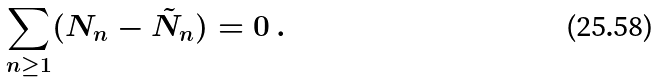<formula> <loc_0><loc_0><loc_500><loc_500>\sum _ { n \geq 1 } ( N _ { n } - \tilde { N } _ { n } ) = 0 \, .</formula> 